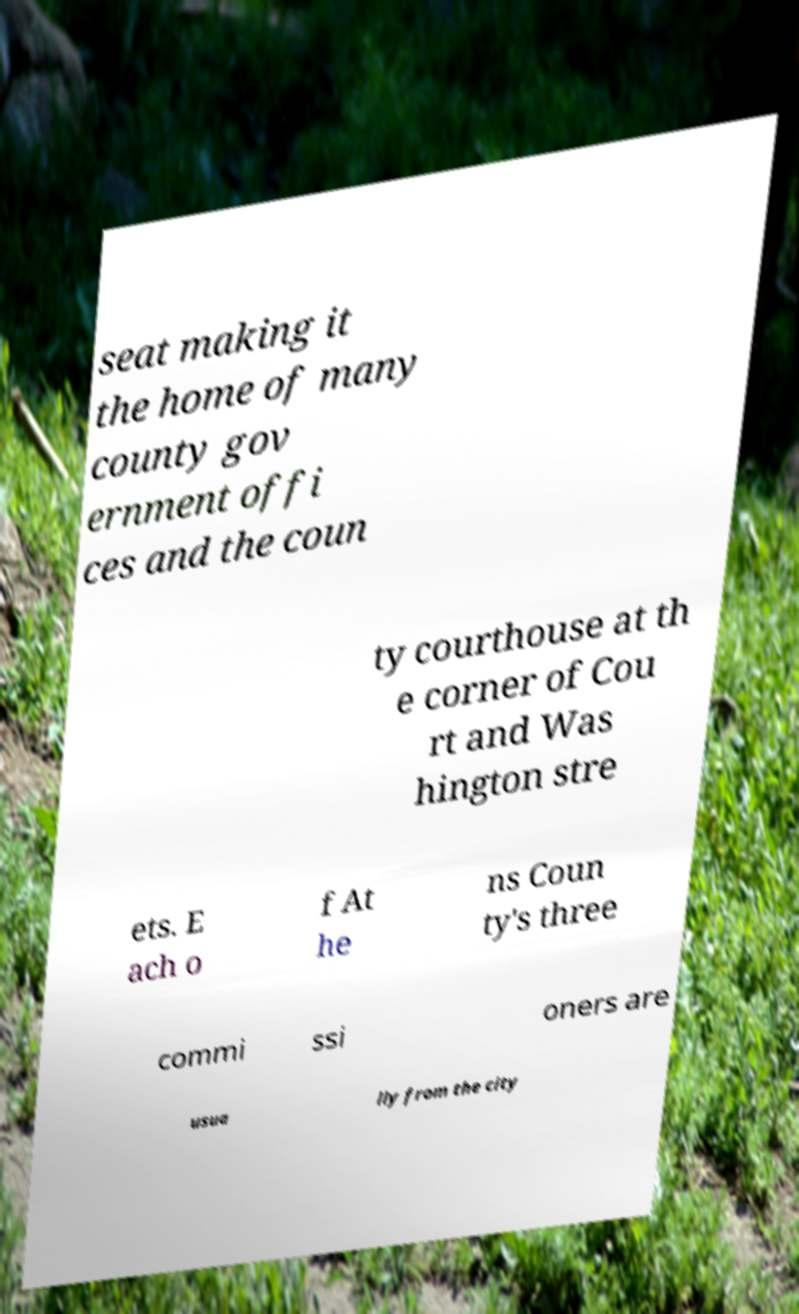I need the written content from this picture converted into text. Can you do that? seat making it the home of many county gov ernment offi ces and the coun ty courthouse at th e corner of Cou rt and Was hington stre ets. E ach o f At he ns Coun ty's three commi ssi oners are usua lly from the city 